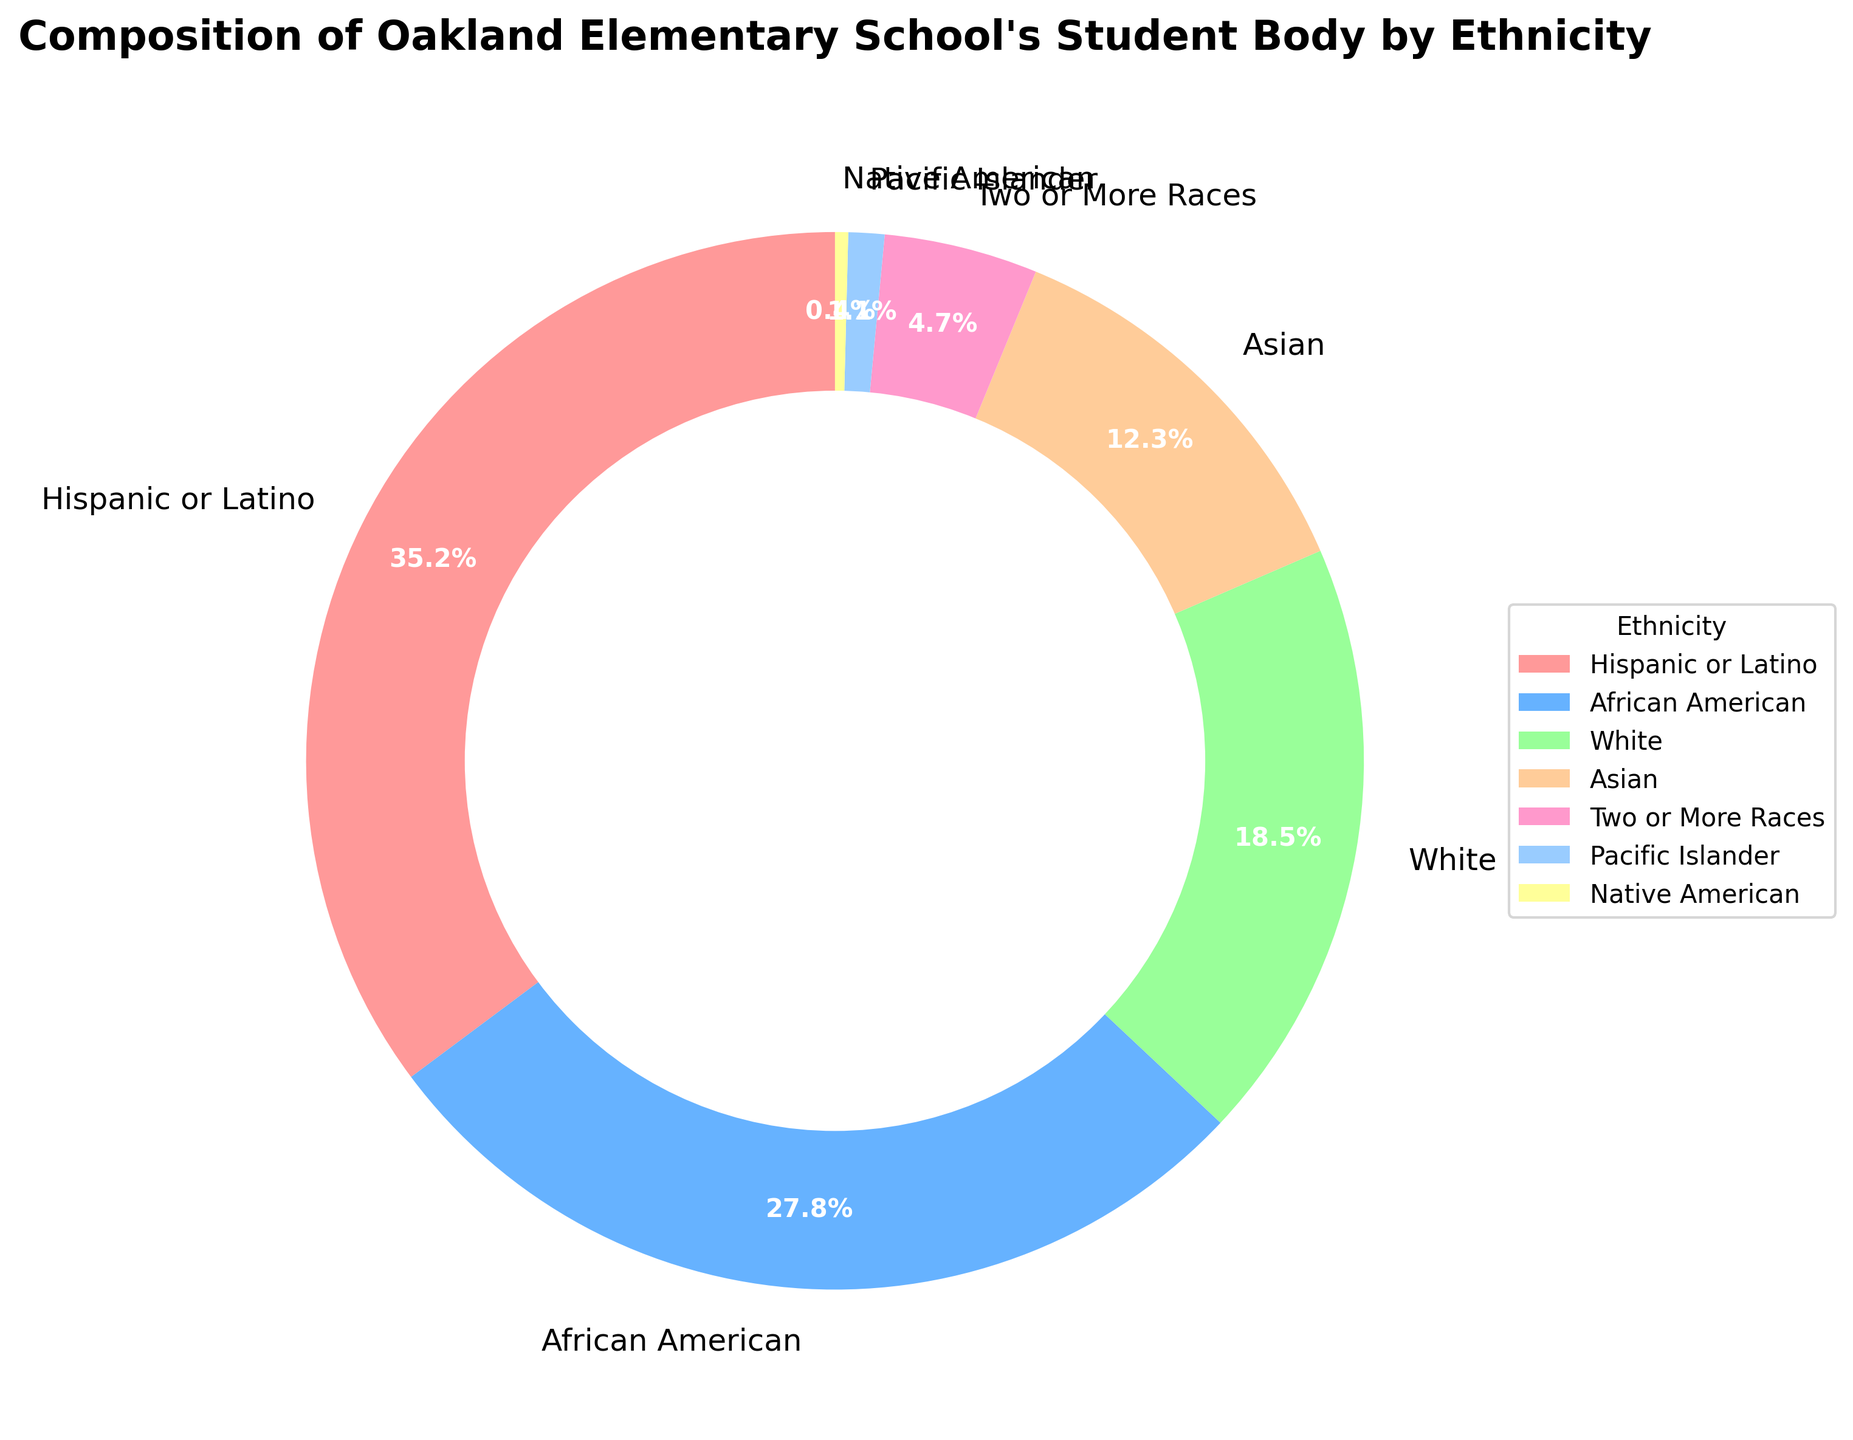What is the percentage of students who are either White or Asian? Sum the percentages of White and Asian students. White: 18.5%, Asian: 12.3%, so 18.5% + 12.3% = 30.8%
Answer: 30.8% Which ethnic group has the smallest percentage in the student body? Compare all the percentages. The smallest percentage is 0.4%, which corresponds to Native American.
Answer: Native American How much larger is the percentage of Hispanic or Latino students compared to Pacific Islander students? Subtract the percentage of Pacific Islander students from Hispanic or Latino students. Hispanic or Latino: 35.2%, Pacific Islander: 1.1%, so 35.2% - 1.1% = 34.1%
Answer: 34.1% What is the combined percentage of African American and Two or More Races students? Sum the percentages of African American and Two or More Races students. African American: 27.8%, Two or More Races: 4.7%, so 27.8% + 4.7% = 32.5%
Answer: 32.5% Which two ethnic groups have the closest percentages? Compare the differences between all pairs of percentages. The smallest difference is between African American (27.8%) and White (18.5%), but it's 9.3%. For closer values, compare Asian (12.3%) and Two or More Races (4.7%) which differ by 7.6%, this is actually larger than the previous comparison's difference, so the smallest one is African American and White.
Answer: African American and White What is the difference in percentage between Hispanic or Latino and African American students? Subtract the percentage of African American students from Hispanic or Latino students. Hispanic or Latino: 35.2%, African American: 27.8%, so 35.2% - 27.8% = 7.4%
Answer: 7.4% Which ethnic group is represented by the green color in the pie chart? Identify the color representation in the pie chart's legend. The green color corresponds to Asian students.
Answer: Asian By how much does the percentage of Hispanic or Latino students exceed the combined percentage of Native American and Pacific Islander students? First, find the combined percentage of Native American and Pacific Islander students: Native American: 0.4%, Pacific Islander: 1.1%, so 0.4% + 1.1% = 1.5%. Then subtract this from the Hispanic or Latino percentage: 35.2% - 1.5% = 33.7%
Answer: 33.7% What is the percentage difference between White and Two or More Races students? Subtract the percentage of Two or More Races students from White students. White: 18.5%, Two or More Races: 4.7%, so 18.5% - 4.7% = 13.8%
Answer: 13.8% What percentages do the ethnic groups represented by the red and blue colors have in total? Identify the percentages for the groups represented by red and blue colors (Hispanic or Latino, African American) and sum them. Hispanic or Latino: 35.2%, African American: 27.8%, so 35.2% + 27.8% = 63%
Answer: 63% 